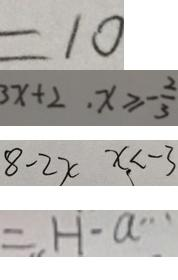Convert formula to latex. <formula><loc_0><loc_0><loc_500><loc_500>= 1 0 
 3 x + 2 \cdot x \geq - \frac { 2 } { 3 } 
 8 - 2 x x < - 3 
 = H \cdot a \cdots</formula> 